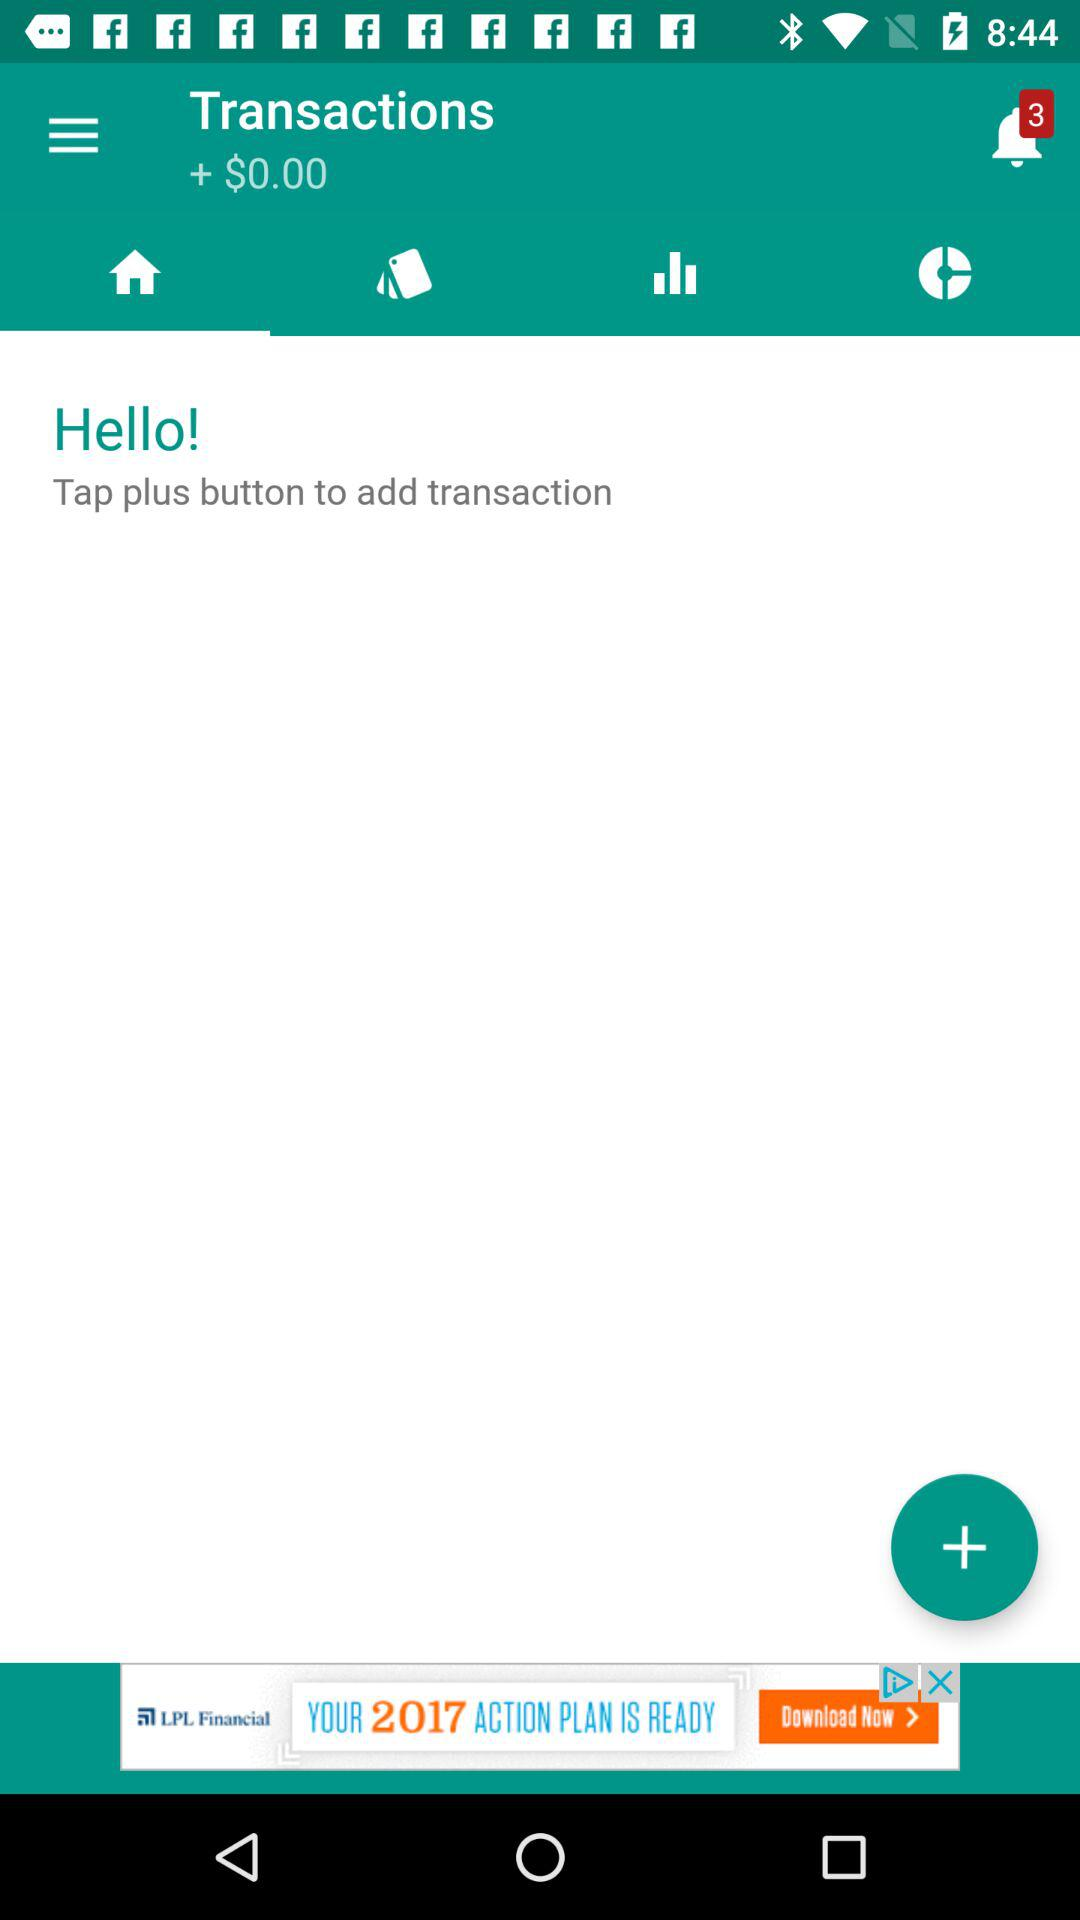What is the sum of the amount of money in all the transactions?
Answer the question using a single word or phrase. $0.00 